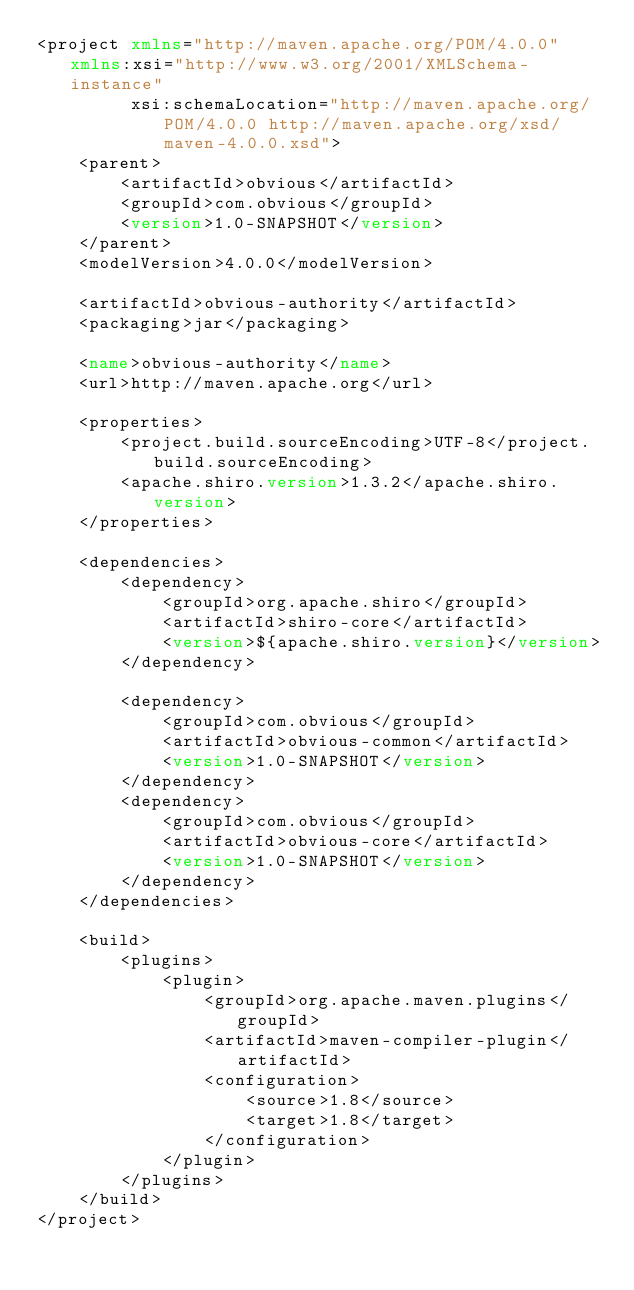<code> <loc_0><loc_0><loc_500><loc_500><_XML_><project xmlns="http://maven.apache.org/POM/4.0.0" xmlns:xsi="http://www.w3.org/2001/XMLSchema-instance"
         xsi:schemaLocation="http://maven.apache.org/POM/4.0.0 http://maven.apache.org/xsd/maven-4.0.0.xsd">
    <parent>
        <artifactId>obvious</artifactId>
        <groupId>com.obvious</groupId>
        <version>1.0-SNAPSHOT</version>
    </parent>
    <modelVersion>4.0.0</modelVersion>

    <artifactId>obvious-authority</artifactId>
    <packaging>jar</packaging>

    <name>obvious-authority</name>
    <url>http://maven.apache.org</url>

    <properties>
        <project.build.sourceEncoding>UTF-8</project.build.sourceEncoding>
        <apache.shiro.version>1.3.2</apache.shiro.version>
    </properties>

    <dependencies>
        <dependency>
            <groupId>org.apache.shiro</groupId>
            <artifactId>shiro-core</artifactId>
            <version>${apache.shiro.version}</version>
        </dependency>

        <dependency>
            <groupId>com.obvious</groupId>
            <artifactId>obvious-common</artifactId>
            <version>1.0-SNAPSHOT</version>
        </dependency>
        <dependency>
            <groupId>com.obvious</groupId>
            <artifactId>obvious-core</artifactId>
            <version>1.0-SNAPSHOT</version>
        </dependency>
    </dependencies>

    <build>
        <plugins>
            <plugin>
                <groupId>org.apache.maven.plugins</groupId>
                <artifactId>maven-compiler-plugin</artifactId>
                <configuration>
                    <source>1.8</source>
                    <target>1.8</target>
                </configuration>
            </plugin>
        </plugins>
    </build>
</project>
</code> 